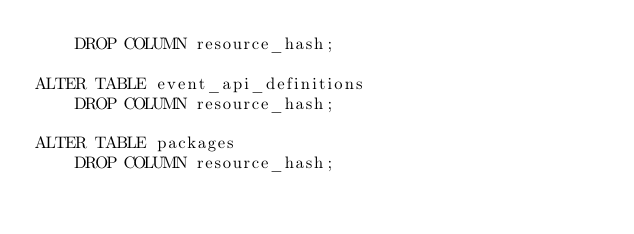<code> <loc_0><loc_0><loc_500><loc_500><_SQL_>    DROP COLUMN resource_hash;

ALTER TABLE event_api_definitions
    DROP COLUMN resource_hash;

ALTER TABLE packages
    DROP COLUMN resource_hash;
</code> 